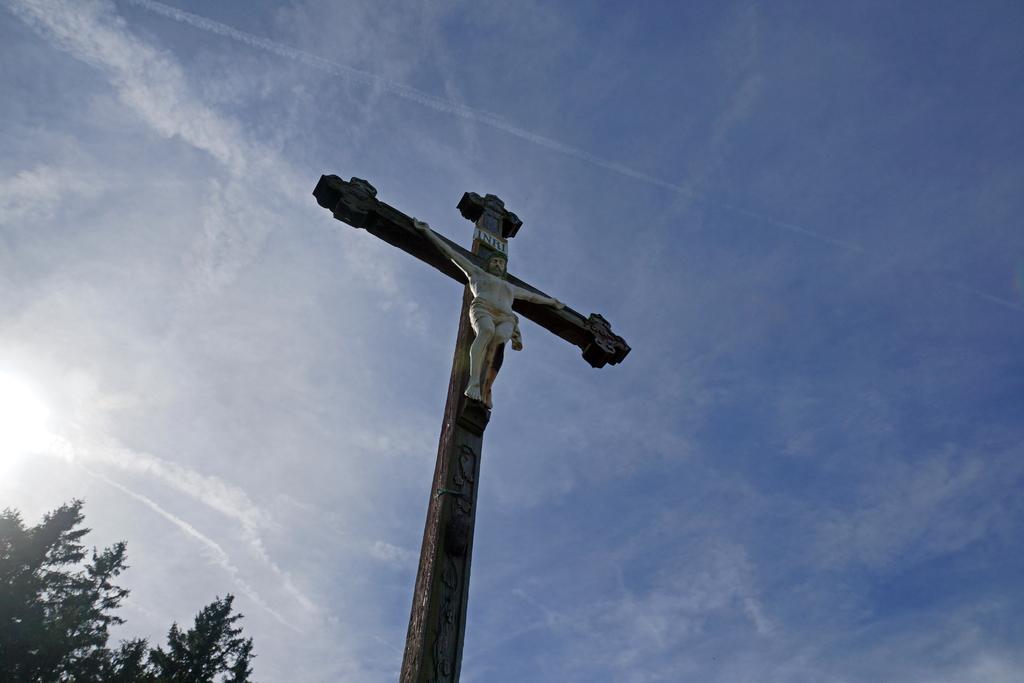In one or two sentences, can you explain what this image depicts? In this image we can see a blue and slightly cloudy sky. There is a sun at the left side of the image. There is a tree in the image. There is a cross symbol in the image. There is a sculpture of a person on the cross symbol. 